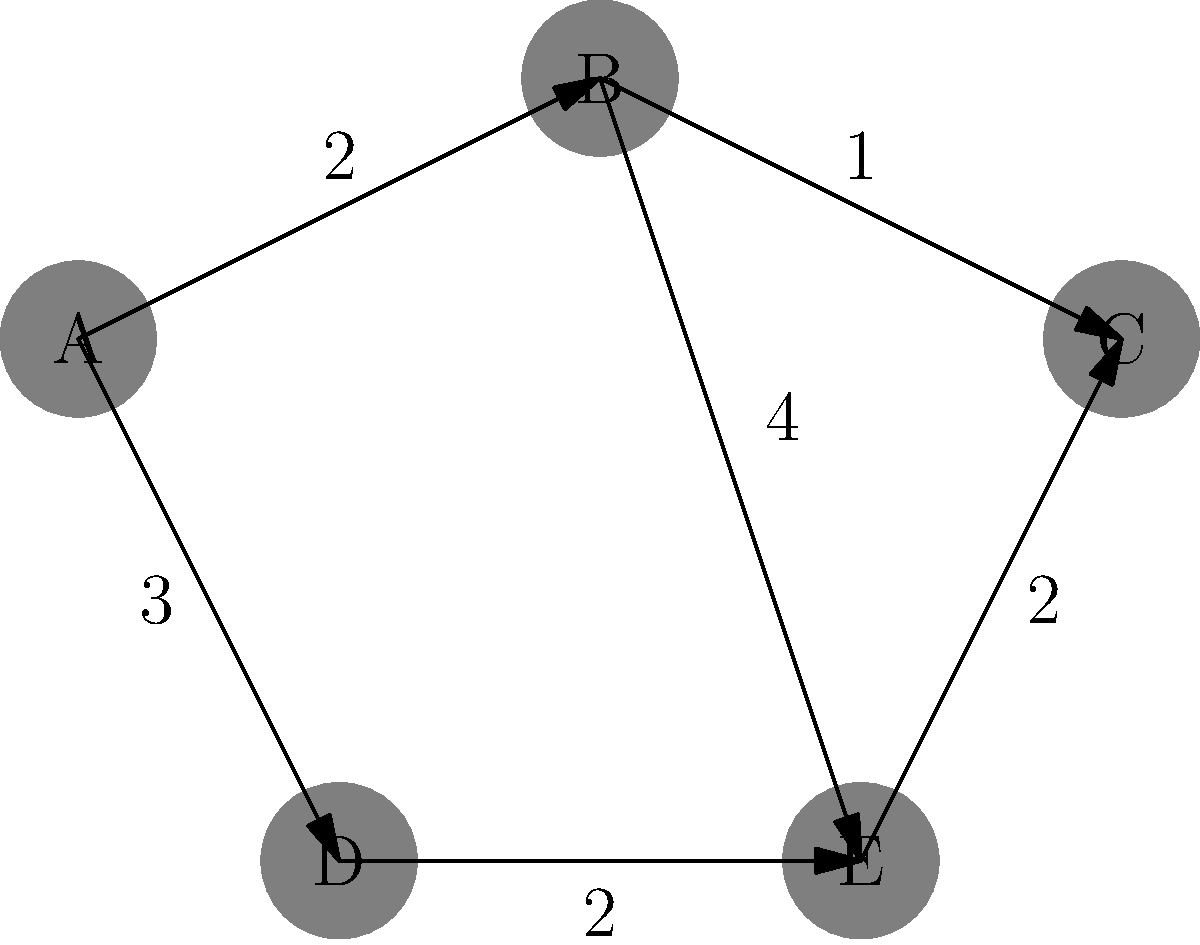In the graph above, nodes represent hip-hop artists, and edges represent collaborations between them. The weight of each edge indicates the number of collaborations. What is the shortest path from artist A to artist C, and what is the total number of collaborations along this path? To find the shortest path from A to C, we'll use Dijkstra's algorithm:

1. Initialize:
   - Distance to A: 0
   - Distance to all other nodes: $\infty$

2. Visit A:
   - Update B: 0 + 2 = 2
   - Update D: 0 + 3 = 3

3. Visit B (closest unvisited node):
   - Update C: 2 + 1 = 3
   - Update E: 2 + 4 = 6

4. Visit C and D (tied for closest unvisited node):
   - C is our target, so we're done

The shortest path is A → B → C, with a total weight of 3.

This path represents:
- 2 collaborations between A and B
- 1 collaboration between B and C

Total number of collaborations: 2 + 1 = 3
Answer: A → B → C, 3 collaborations 